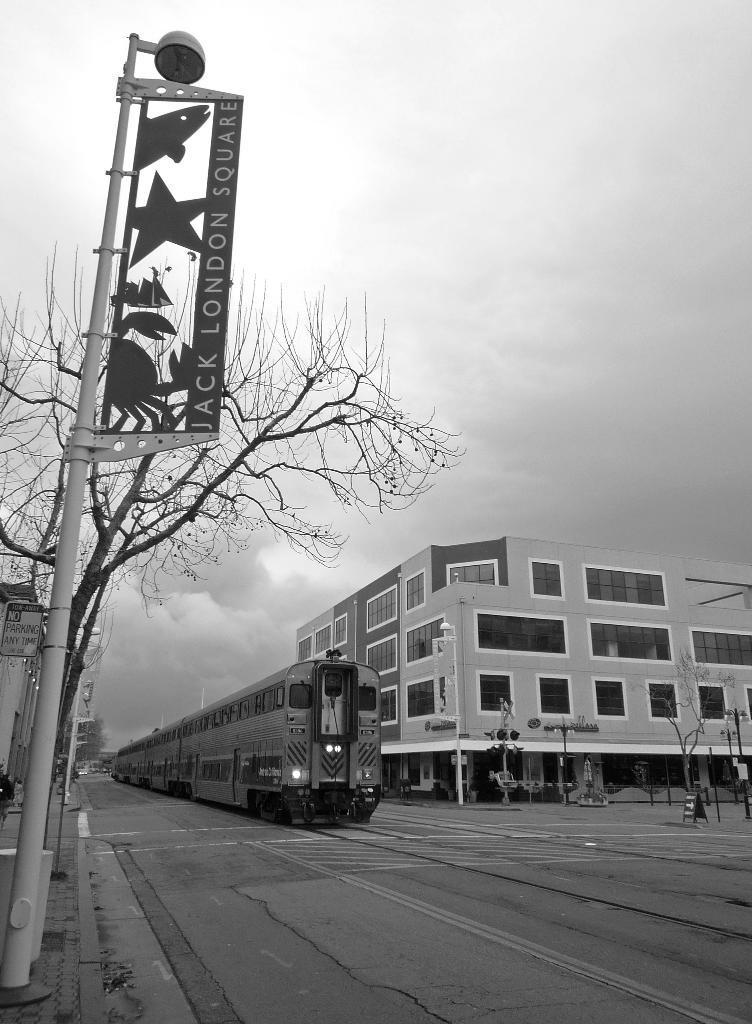In one or two sentences, can you explain what this image depicts? This is a black and white image. In the center of the image there is a train. To the right side of the image there is a building. In the foreground of the image there is a pole. there is a tree. at the bottom of the image there is road. At the top of the image there is sky. 